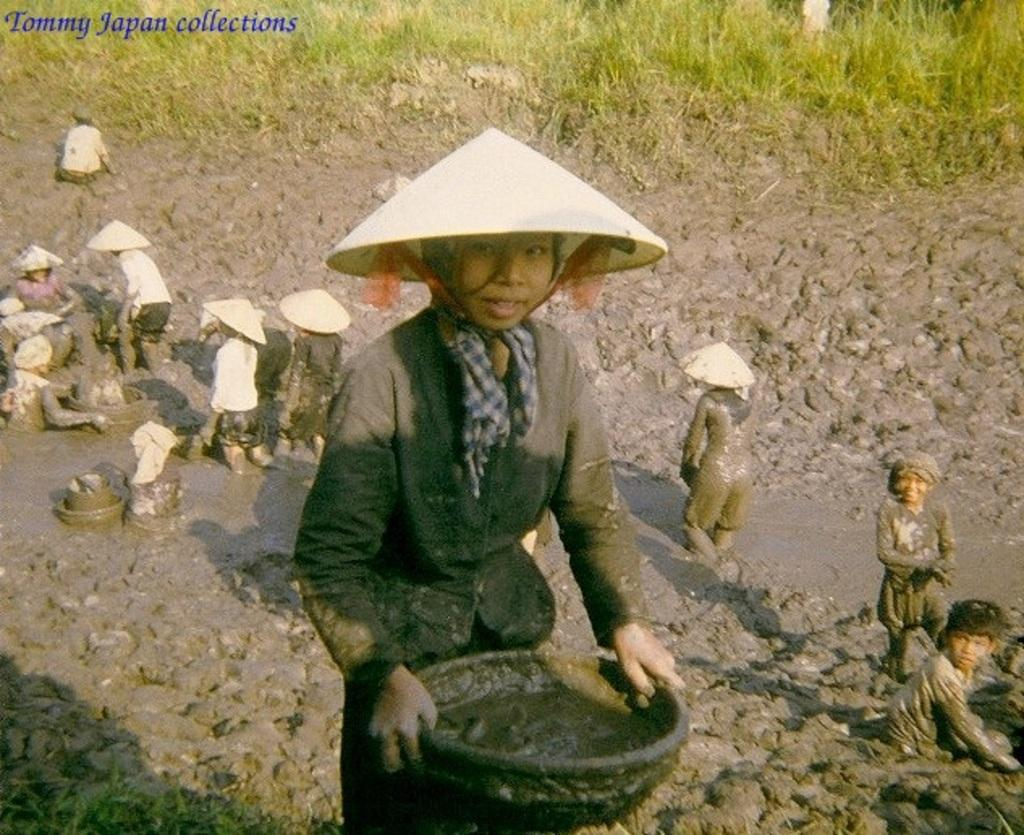How many people are in the image? There are persons in the image, but the exact number is not specified. What are the persons wearing on their heads? The persons are wearing caps. Where can text be found in the image? The text is located in the top left hand side of the image. What type of vegetation is present at the top of the image? There are plants at the top of the image. What type of fowl can be seen perched on the stick in the image? There is no fowl or stick present in the image. How many snakes are visible in the image? There are no snakes visible in the image. 